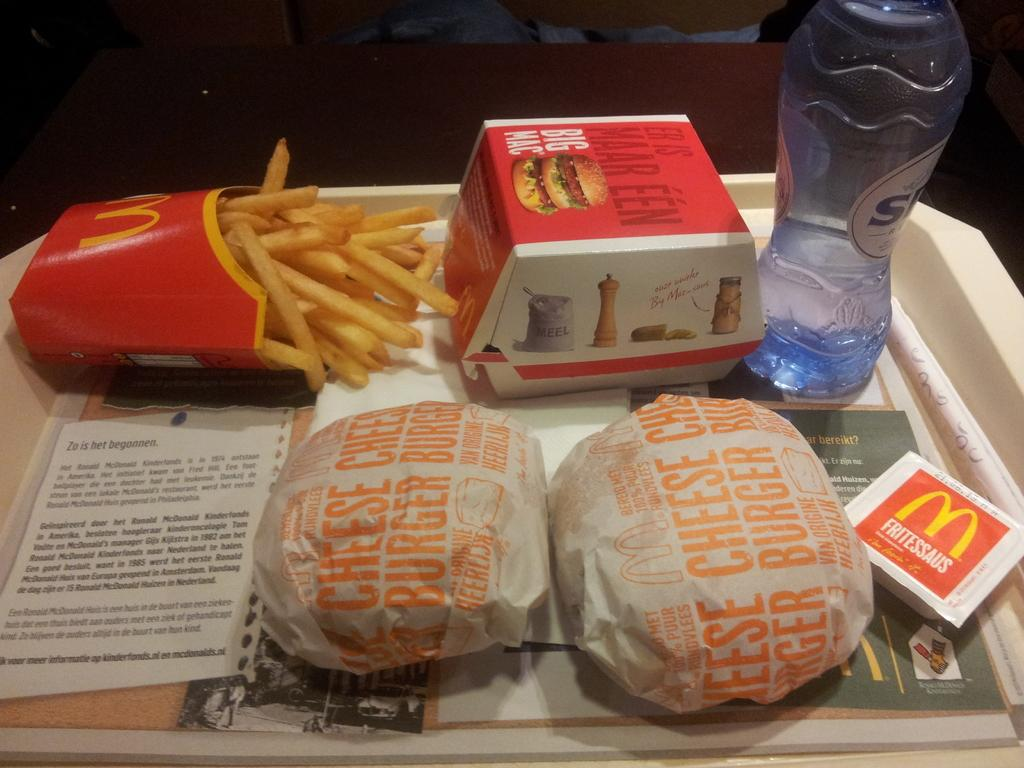What is on the tray in the image? There is a food item on the tray. What type of snack is present in the image? There are potato chips in a box on the tray. What beverage is available on the tray? There is a bottle filled with water on the tray. How many heads of lettuce can be seen on the tray? There is no lettuce present on the tray in the image. What type of dinosaur is visible on the tray? There are no dinosaurs present on the tray in the image. 